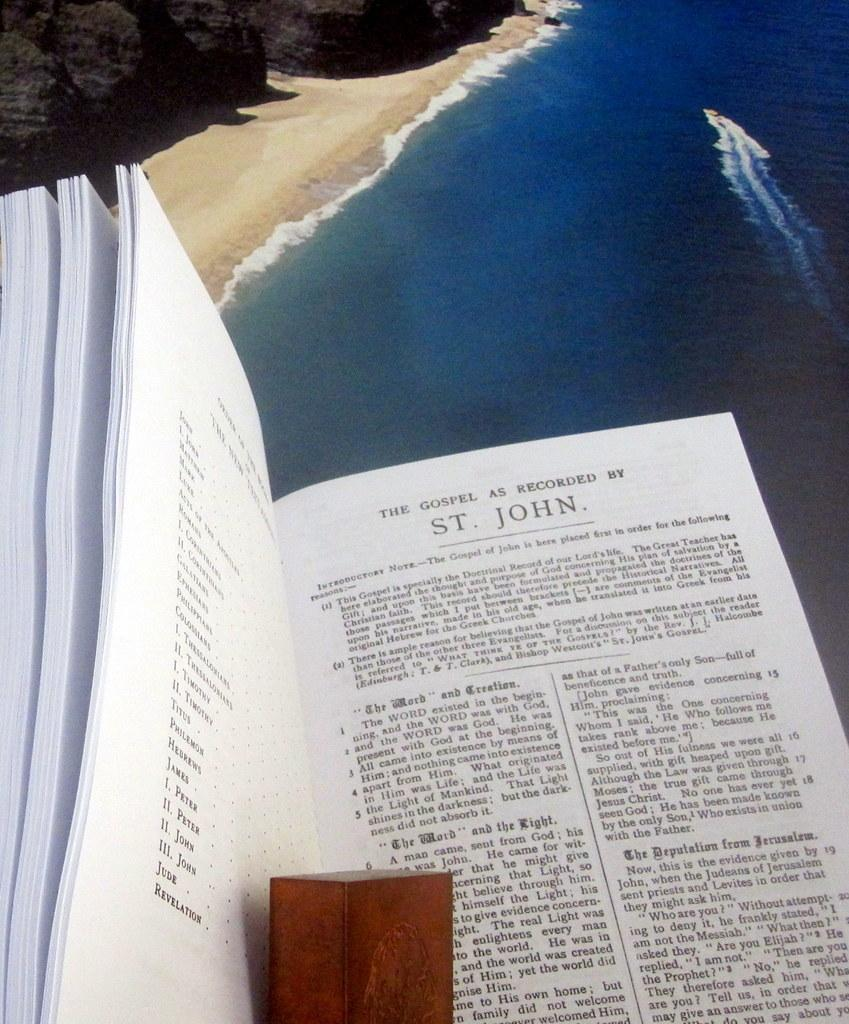Provide a one-sentence caption for the provided image. A booked titled The gospel as Recorded by St. Joseph is sitting above a blue ocean. 